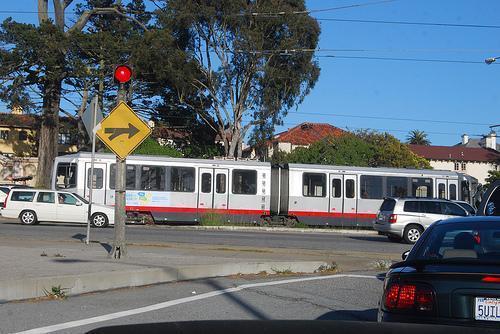How many white cars are there?
Give a very brief answer. 1. 